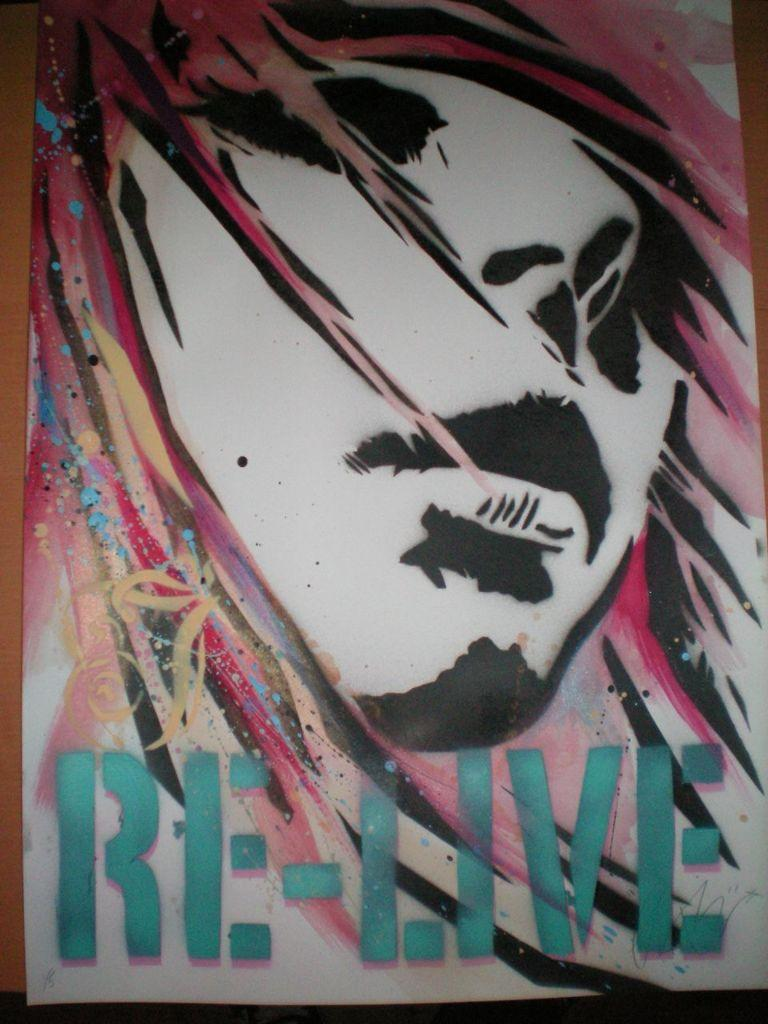What is depicted in the picture? There is a drawing of a girl in the picture. Where is the drawing located? The drawing is on a poster. Is there any text on the poster? Yes, there is a small quote written on the bottom side of the poster. What type of zephyr can be seen interacting with the girl in the drawing? There is no zephyr present in the image, and the drawing does not depict any interaction between the girl and a zephyr. 